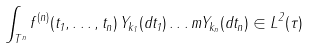Convert formula to latex. <formula><loc_0><loc_0><loc_500><loc_500>\int _ { T ^ { n } } f ^ { ( n ) } ( t _ { 1 } , \dots , t _ { n } ) \, Y _ { k _ { 1 } } ( d t _ { 1 } ) \dots m Y _ { k _ { n } } ( d t _ { n } ) \in L ^ { 2 } ( \tau )</formula> 